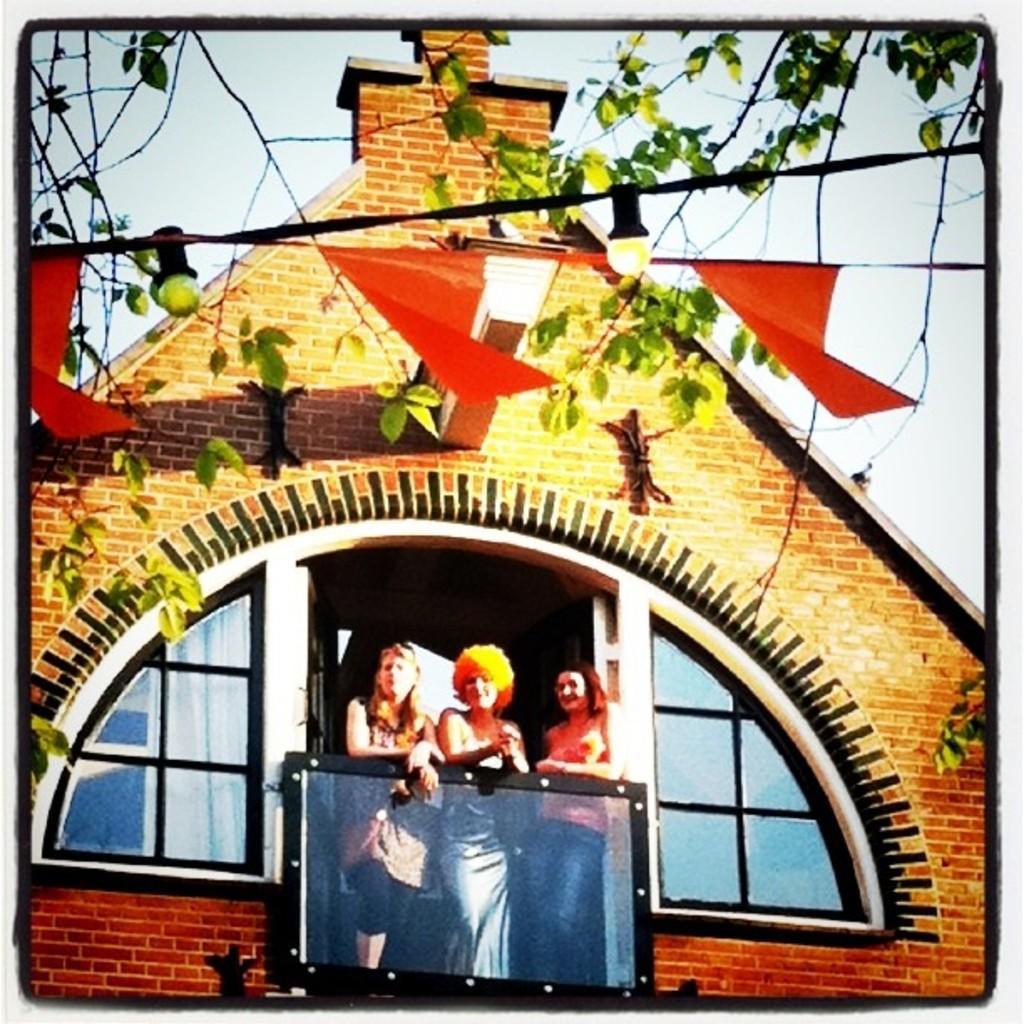Can you describe this image briefly? Here in this picture we can see three women standing in a balcony of a building and in the front we can see some decoration papers and lights present and we can also see branches of plants present and we can see the sky is clear. 